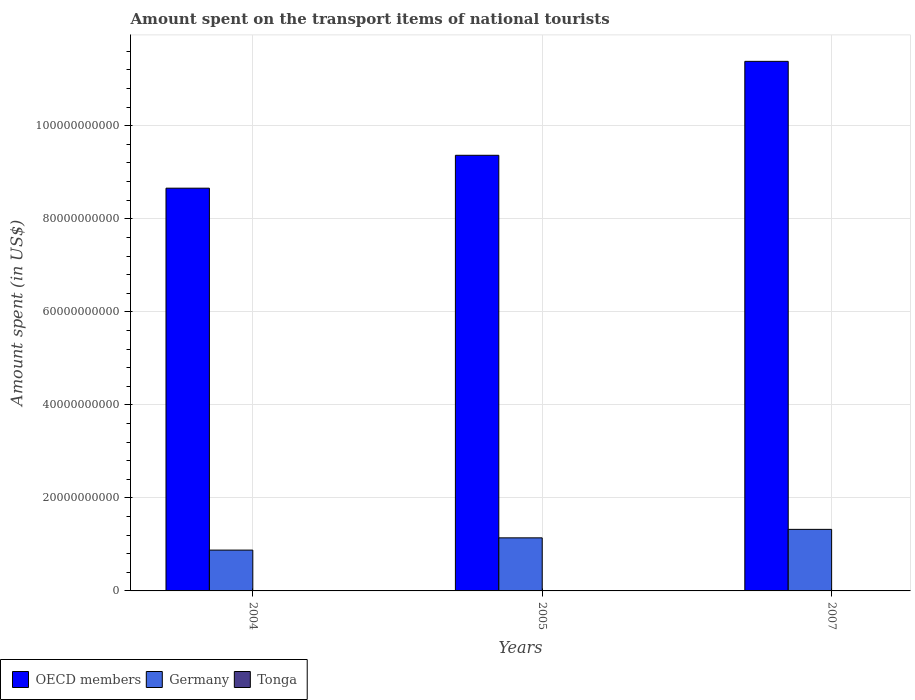How many different coloured bars are there?
Offer a terse response. 3. How many groups of bars are there?
Make the answer very short. 3. Are the number of bars per tick equal to the number of legend labels?
Keep it short and to the point. Yes. Are the number of bars on each tick of the X-axis equal?
Provide a succinct answer. Yes. In how many cases, is the number of bars for a given year not equal to the number of legend labels?
Keep it short and to the point. 0. What is the amount spent on the transport items of national tourists in Tonga in 2007?
Provide a short and direct response. 8.00e+05. Across all years, what is the maximum amount spent on the transport items of national tourists in Germany?
Your answer should be very brief. 1.32e+1. Across all years, what is the minimum amount spent on the transport items of national tourists in Germany?
Provide a succinct answer. 8.78e+09. In which year was the amount spent on the transport items of national tourists in Germany maximum?
Your response must be concise. 2007. In which year was the amount spent on the transport items of national tourists in OECD members minimum?
Your response must be concise. 2004. What is the total amount spent on the transport items of national tourists in OECD members in the graph?
Keep it short and to the point. 2.94e+11. What is the difference between the amount spent on the transport items of national tourists in OECD members in 2005 and that in 2007?
Your answer should be very brief. -2.02e+1. What is the difference between the amount spent on the transport items of national tourists in Tonga in 2007 and the amount spent on the transport items of national tourists in Germany in 2005?
Provide a succinct answer. -1.14e+1. What is the average amount spent on the transport items of national tourists in Germany per year?
Offer a very short reply. 1.11e+1. In the year 2005, what is the difference between the amount spent on the transport items of national tourists in OECD members and amount spent on the transport items of national tourists in Germany?
Your answer should be compact. 8.22e+1. What is the ratio of the amount spent on the transport items of national tourists in OECD members in 2004 to that in 2007?
Make the answer very short. 0.76. Is the amount spent on the transport items of national tourists in Germany in 2004 less than that in 2005?
Make the answer very short. Yes. Is the difference between the amount spent on the transport items of national tourists in OECD members in 2004 and 2005 greater than the difference between the amount spent on the transport items of national tourists in Germany in 2004 and 2005?
Provide a succinct answer. No. What is the difference between the highest and the second highest amount spent on the transport items of national tourists in OECD members?
Your response must be concise. 2.02e+1. What is the difference between the highest and the lowest amount spent on the transport items of national tourists in OECD members?
Your response must be concise. 2.73e+1. In how many years, is the amount spent on the transport items of national tourists in Germany greater than the average amount spent on the transport items of national tourists in Germany taken over all years?
Make the answer very short. 2. What does the 2nd bar from the left in 2007 represents?
Provide a succinct answer. Germany. Is it the case that in every year, the sum of the amount spent on the transport items of national tourists in Tonga and amount spent on the transport items of national tourists in OECD members is greater than the amount spent on the transport items of national tourists in Germany?
Provide a short and direct response. Yes. How many bars are there?
Offer a very short reply. 9. How many years are there in the graph?
Offer a terse response. 3. Are the values on the major ticks of Y-axis written in scientific E-notation?
Ensure brevity in your answer.  No. Does the graph contain grids?
Your response must be concise. Yes. What is the title of the graph?
Make the answer very short. Amount spent on the transport items of national tourists. What is the label or title of the Y-axis?
Make the answer very short. Amount spent (in US$). What is the Amount spent (in US$) in OECD members in 2004?
Give a very brief answer. 8.66e+1. What is the Amount spent (in US$) of Germany in 2004?
Provide a succinct answer. 8.78e+09. What is the Amount spent (in US$) of OECD members in 2005?
Your answer should be very brief. 9.37e+1. What is the Amount spent (in US$) of Germany in 2005?
Offer a terse response. 1.14e+1. What is the Amount spent (in US$) in OECD members in 2007?
Keep it short and to the point. 1.14e+11. What is the Amount spent (in US$) of Germany in 2007?
Offer a terse response. 1.32e+1. Across all years, what is the maximum Amount spent (in US$) in OECD members?
Your answer should be very brief. 1.14e+11. Across all years, what is the maximum Amount spent (in US$) in Germany?
Provide a short and direct response. 1.32e+1. Across all years, what is the maximum Amount spent (in US$) in Tonga?
Offer a terse response. 8.00e+05. Across all years, what is the minimum Amount spent (in US$) of OECD members?
Provide a short and direct response. 8.66e+1. Across all years, what is the minimum Amount spent (in US$) of Germany?
Offer a terse response. 8.78e+09. What is the total Amount spent (in US$) of OECD members in the graph?
Provide a succinct answer. 2.94e+11. What is the total Amount spent (in US$) of Germany in the graph?
Provide a succinct answer. 3.34e+1. What is the total Amount spent (in US$) in Tonga in the graph?
Offer a terse response. 1.20e+06. What is the difference between the Amount spent (in US$) of OECD members in 2004 and that in 2005?
Your answer should be very brief. -7.07e+09. What is the difference between the Amount spent (in US$) of Germany in 2004 and that in 2005?
Provide a succinct answer. -2.63e+09. What is the difference between the Amount spent (in US$) of Tonga in 2004 and that in 2005?
Give a very brief answer. 2.00e+05. What is the difference between the Amount spent (in US$) in OECD members in 2004 and that in 2007?
Give a very brief answer. -2.73e+1. What is the difference between the Amount spent (in US$) in Germany in 2004 and that in 2007?
Ensure brevity in your answer.  -4.46e+09. What is the difference between the Amount spent (in US$) of Tonga in 2004 and that in 2007?
Your answer should be very brief. -5.00e+05. What is the difference between the Amount spent (in US$) in OECD members in 2005 and that in 2007?
Your answer should be very brief. -2.02e+1. What is the difference between the Amount spent (in US$) in Germany in 2005 and that in 2007?
Keep it short and to the point. -1.82e+09. What is the difference between the Amount spent (in US$) of Tonga in 2005 and that in 2007?
Make the answer very short. -7.00e+05. What is the difference between the Amount spent (in US$) in OECD members in 2004 and the Amount spent (in US$) in Germany in 2005?
Your answer should be compact. 7.52e+1. What is the difference between the Amount spent (in US$) of OECD members in 2004 and the Amount spent (in US$) of Tonga in 2005?
Your answer should be very brief. 8.66e+1. What is the difference between the Amount spent (in US$) in Germany in 2004 and the Amount spent (in US$) in Tonga in 2005?
Make the answer very short. 8.78e+09. What is the difference between the Amount spent (in US$) of OECD members in 2004 and the Amount spent (in US$) of Germany in 2007?
Make the answer very short. 7.33e+1. What is the difference between the Amount spent (in US$) of OECD members in 2004 and the Amount spent (in US$) of Tonga in 2007?
Give a very brief answer. 8.66e+1. What is the difference between the Amount spent (in US$) of Germany in 2004 and the Amount spent (in US$) of Tonga in 2007?
Keep it short and to the point. 8.78e+09. What is the difference between the Amount spent (in US$) of OECD members in 2005 and the Amount spent (in US$) of Germany in 2007?
Ensure brevity in your answer.  8.04e+1. What is the difference between the Amount spent (in US$) in OECD members in 2005 and the Amount spent (in US$) in Tonga in 2007?
Offer a very short reply. 9.37e+1. What is the difference between the Amount spent (in US$) in Germany in 2005 and the Amount spent (in US$) in Tonga in 2007?
Ensure brevity in your answer.  1.14e+1. What is the average Amount spent (in US$) of OECD members per year?
Offer a terse response. 9.80e+1. What is the average Amount spent (in US$) in Germany per year?
Keep it short and to the point. 1.11e+1. What is the average Amount spent (in US$) of Tonga per year?
Offer a very short reply. 4.00e+05. In the year 2004, what is the difference between the Amount spent (in US$) in OECD members and Amount spent (in US$) in Germany?
Provide a succinct answer. 7.78e+1. In the year 2004, what is the difference between the Amount spent (in US$) of OECD members and Amount spent (in US$) of Tonga?
Give a very brief answer. 8.66e+1. In the year 2004, what is the difference between the Amount spent (in US$) in Germany and Amount spent (in US$) in Tonga?
Offer a terse response. 8.78e+09. In the year 2005, what is the difference between the Amount spent (in US$) in OECD members and Amount spent (in US$) in Germany?
Provide a short and direct response. 8.22e+1. In the year 2005, what is the difference between the Amount spent (in US$) of OECD members and Amount spent (in US$) of Tonga?
Give a very brief answer. 9.37e+1. In the year 2005, what is the difference between the Amount spent (in US$) in Germany and Amount spent (in US$) in Tonga?
Provide a succinct answer. 1.14e+1. In the year 2007, what is the difference between the Amount spent (in US$) in OECD members and Amount spent (in US$) in Germany?
Offer a terse response. 1.01e+11. In the year 2007, what is the difference between the Amount spent (in US$) in OECD members and Amount spent (in US$) in Tonga?
Your response must be concise. 1.14e+11. In the year 2007, what is the difference between the Amount spent (in US$) of Germany and Amount spent (in US$) of Tonga?
Your response must be concise. 1.32e+1. What is the ratio of the Amount spent (in US$) in OECD members in 2004 to that in 2005?
Provide a short and direct response. 0.92. What is the ratio of the Amount spent (in US$) in Germany in 2004 to that in 2005?
Offer a terse response. 0.77. What is the ratio of the Amount spent (in US$) in Tonga in 2004 to that in 2005?
Ensure brevity in your answer.  3. What is the ratio of the Amount spent (in US$) in OECD members in 2004 to that in 2007?
Keep it short and to the point. 0.76. What is the ratio of the Amount spent (in US$) of Germany in 2004 to that in 2007?
Your response must be concise. 0.66. What is the ratio of the Amount spent (in US$) of Tonga in 2004 to that in 2007?
Offer a very short reply. 0.38. What is the ratio of the Amount spent (in US$) of OECD members in 2005 to that in 2007?
Ensure brevity in your answer.  0.82. What is the ratio of the Amount spent (in US$) in Germany in 2005 to that in 2007?
Keep it short and to the point. 0.86. What is the difference between the highest and the second highest Amount spent (in US$) in OECD members?
Keep it short and to the point. 2.02e+1. What is the difference between the highest and the second highest Amount spent (in US$) of Germany?
Give a very brief answer. 1.82e+09. What is the difference between the highest and the second highest Amount spent (in US$) of Tonga?
Your response must be concise. 5.00e+05. What is the difference between the highest and the lowest Amount spent (in US$) in OECD members?
Your response must be concise. 2.73e+1. What is the difference between the highest and the lowest Amount spent (in US$) of Germany?
Provide a succinct answer. 4.46e+09. What is the difference between the highest and the lowest Amount spent (in US$) of Tonga?
Make the answer very short. 7.00e+05. 